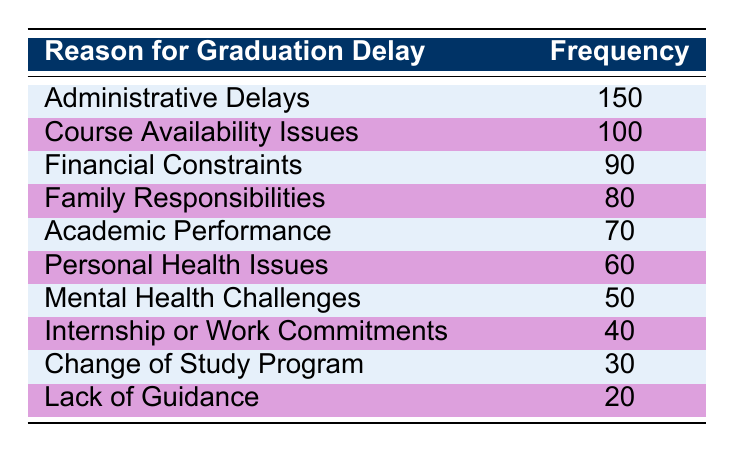What is the most common reason for graduation delay? The highest frequency in the table is for "Administrative Delays," which has a value of 150.
Answer: 150 How many students graduated later due to "Family Responsibilities"? According to the table, the frequency for "Family Responsibilities" is 80.
Answer: 80 What is the combined frequency of "Personal Health Issues" and "Mental Health Challenges"? The frequency for "Personal Health Issues" is 60, and for "Mental Health Challenges" it is 50. Adding those together gives 60 + 50 = 110.
Answer: 110 Is the frequency of "Course Availability Issues" greater than that of "Financial Constraints"? The frequency for "Course Availability Issues" is 100, while "Financial Constraints" has a frequency of 90. Yes, 100 is greater than 90.
Answer: Yes What is the average frequency of delays caused by "Internship or Work Commitments," "Change of Study Program," and "Lack of Guidance"? The frequencies for these reasons are 40, 30, and 20. First, sum them: 40 + 30 + 20 = 90. There are three reasons, so the average is 90/3 = 30.
Answer: 30 Which reason has the second lowest frequency of graduation delays? The lowest frequency is for "Lack of Guidance" with 20. The second lowest is "Change of Study Program" with 30.
Answer: Change of Study Program What reasons, if any, have a frequency greater than 100? By inspecting the table, "Administrative Delays" with 150 and "Course Availability Issues" with 100 are the only reasons that have a frequency greater than 100.
Answer: Administrative Delays, Course Availability Issues What is the total number of graduation delays for all listed reasons? We need to add up all the frequencies listed: 150 + 100 + 90 + 80 + 70 + 60 + 50 + 40 + 30 + 20 = 840.
Answer: 840 How many more students faced delays due to "Administrative Delays" compared to "Internship or Work Commitments"? The frequency for "Administrative Delays" is 150 and for "Internship or Work Commitments" it is 40. The difference is 150 - 40 = 110.
Answer: 110 